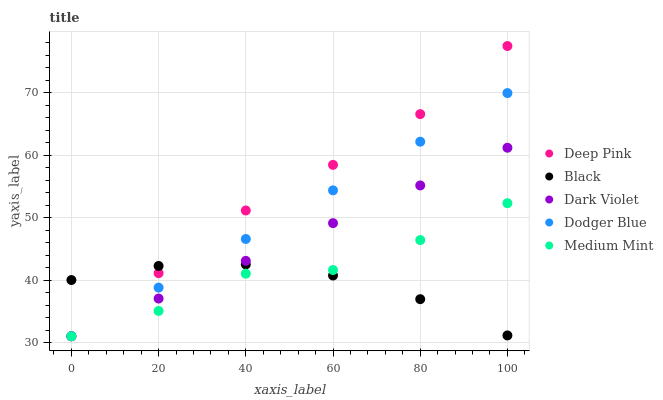Does Black have the minimum area under the curve?
Answer yes or no. Yes. Does Deep Pink have the maximum area under the curve?
Answer yes or no. Yes. Does Dodger Blue have the minimum area under the curve?
Answer yes or no. No. Does Dodger Blue have the maximum area under the curve?
Answer yes or no. No. Is Dodger Blue the smoothest?
Answer yes or no. Yes. Is Medium Mint the roughest?
Answer yes or no. Yes. Is Deep Pink the smoothest?
Answer yes or no. No. Is Deep Pink the roughest?
Answer yes or no. No. Does Medium Mint have the lowest value?
Answer yes or no. Yes. Does Black have the lowest value?
Answer yes or no. No. Does Deep Pink have the highest value?
Answer yes or no. Yes. Does Dodger Blue have the highest value?
Answer yes or no. No. Does Black intersect Dodger Blue?
Answer yes or no. Yes. Is Black less than Dodger Blue?
Answer yes or no. No. Is Black greater than Dodger Blue?
Answer yes or no. No. 